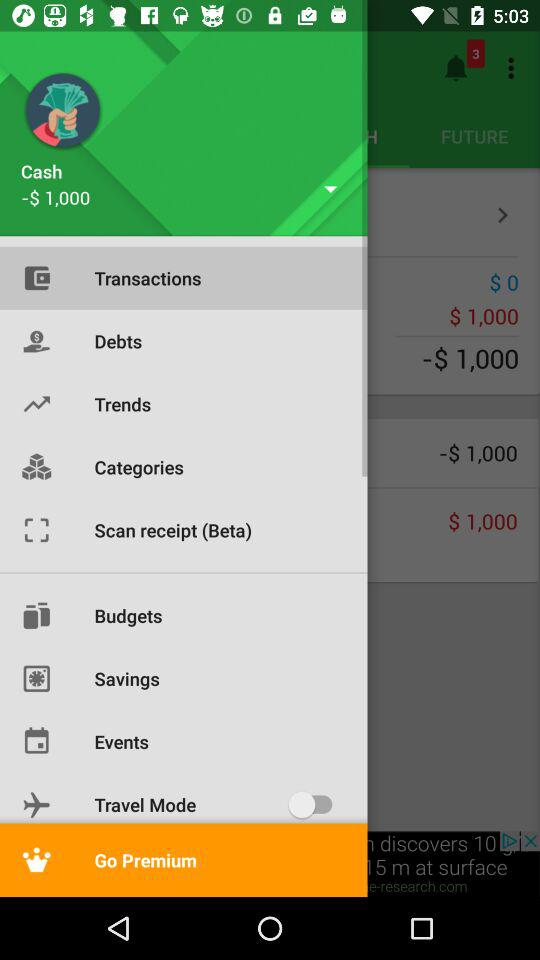What is the status of "Travel Mode"? The status of "Travel Mode" is "off". 